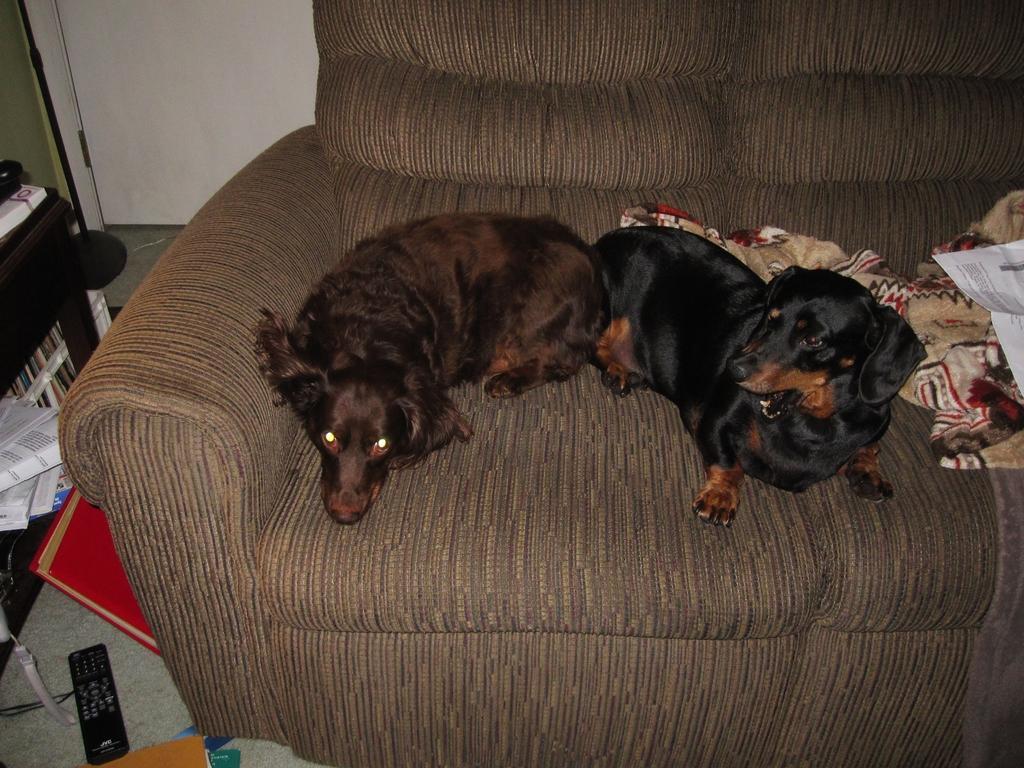How would you summarize this image in a sentence or two? In this image there are two dogs on the sofa, beside the dog there is a blanket and papers. On the left side of the image there is a table with some books arranged and there are few objects placed on the floor. In the background there is a wall. 